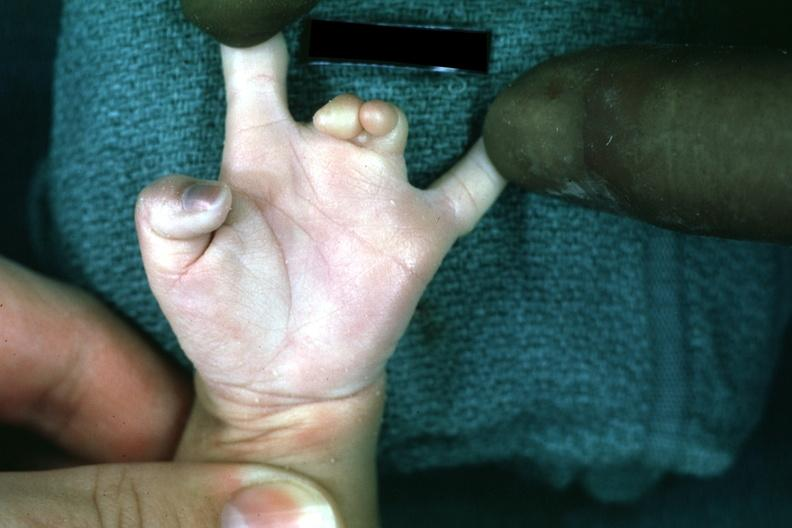re extremities present?
Answer the question using a single word or phrase. Yes 